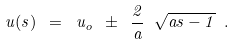Convert formula to latex. <formula><loc_0><loc_0><loc_500><loc_500>u ( s ) \ = \ u _ { o } \ \pm \ \frac { 2 } { a } \ \sqrt { a s - 1 } \ .</formula> 